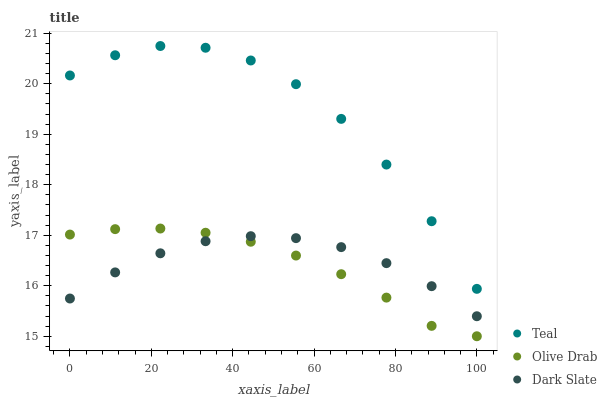Does Olive Drab have the minimum area under the curve?
Answer yes or no. Yes. Does Teal have the maximum area under the curve?
Answer yes or no. Yes. Does Teal have the minimum area under the curve?
Answer yes or no. No. Does Olive Drab have the maximum area under the curve?
Answer yes or no. No. Is Olive Drab the smoothest?
Answer yes or no. Yes. Is Teal the roughest?
Answer yes or no. Yes. Is Teal the smoothest?
Answer yes or no. No. Is Olive Drab the roughest?
Answer yes or no. No. Does Olive Drab have the lowest value?
Answer yes or no. Yes. Does Teal have the lowest value?
Answer yes or no. No. Does Teal have the highest value?
Answer yes or no. Yes. Does Olive Drab have the highest value?
Answer yes or no. No. Is Dark Slate less than Teal?
Answer yes or no. Yes. Is Teal greater than Olive Drab?
Answer yes or no. Yes. Does Dark Slate intersect Olive Drab?
Answer yes or no. Yes. Is Dark Slate less than Olive Drab?
Answer yes or no. No. Is Dark Slate greater than Olive Drab?
Answer yes or no. No. Does Dark Slate intersect Teal?
Answer yes or no. No. 